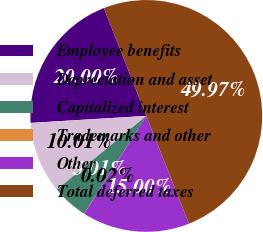<chart> <loc_0><loc_0><loc_500><loc_500><pie_chart><fcel>Employee benefits<fcel>Depreciation and asset<fcel>Capitalized interest<fcel>Trademarks and other<fcel>Other<fcel>Total deferred taxes<nl><fcel>20.0%<fcel>10.01%<fcel>5.01%<fcel>0.02%<fcel>15.0%<fcel>49.97%<nl></chart> 